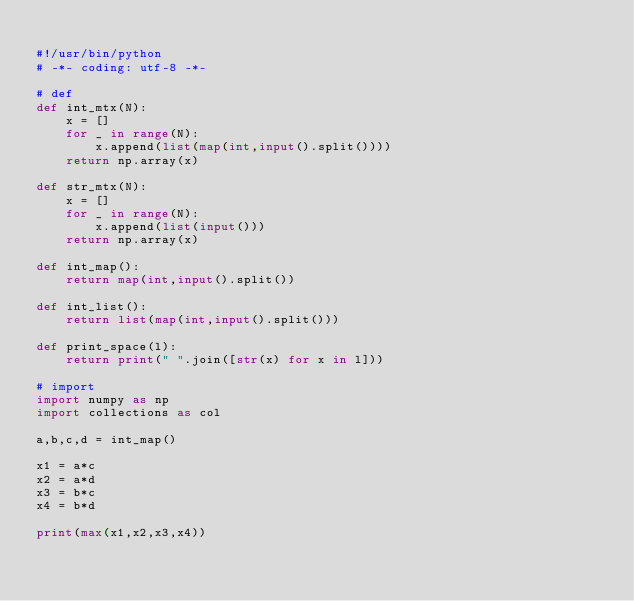Convert code to text. <code><loc_0><loc_0><loc_500><loc_500><_Python_>
#!/usr/bin/python
# -*- coding: utf-8 -*-

# def
def int_mtx(N):
    x = []
    for _ in range(N):
        x.append(list(map(int,input().split())))
    return np.array(x)

def str_mtx(N):
    x = []
    for _ in range(N):
        x.append(list(input()))
    return np.array(x)

def int_map():
    return map(int,input().split())

def int_list():
    return list(map(int,input().split()))

def print_space(l):
    return print(" ".join([str(x) for x in l]))

# import
import numpy as np
import collections as col

a,b,c,d = int_map()

x1 = a*c
x2 = a*d
x3 = b*c
x4 = b*d

print(max(x1,x2,x3,x4))</code> 